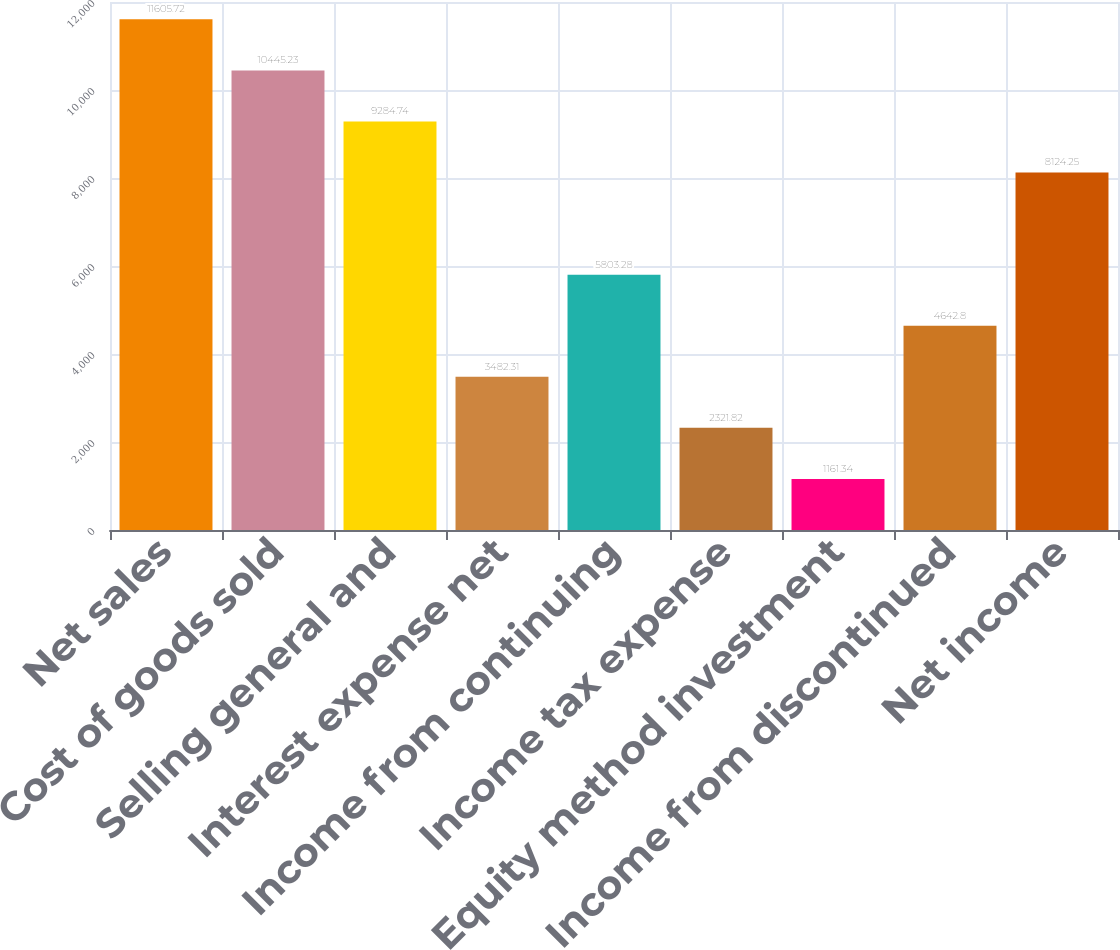<chart> <loc_0><loc_0><loc_500><loc_500><bar_chart><fcel>Net sales<fcel>Cost of goods sold<fcel>Selling general and<fcel>Interest expense net<fcel>Income from continuing<fcel>Income tax expense<fcel>Equity method investment<fcel>Income from discontinued<fcel>Net income<nl><fcel>11605.7<fcel>10445.2<fcel>9284.74<fcel>3482.31<fcel>5803.28<fcel>2321.82<fcel>1161.34<fcel>4642.8<fcel>8124.25<nl></chart> 